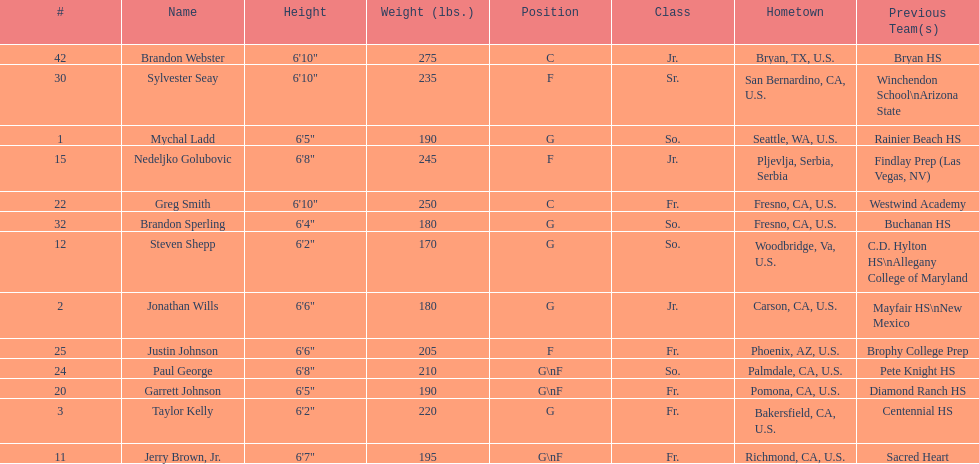Which player previously played for sacred heart? Jerry Brown, Jr. 